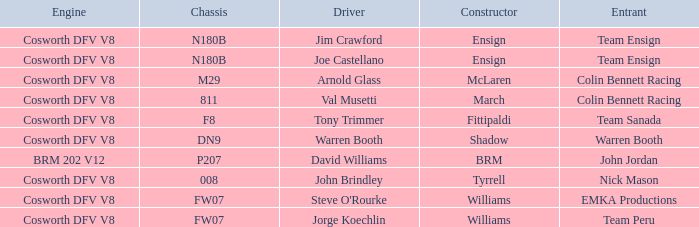Which group operated the brm assembled car? John Jordan. 